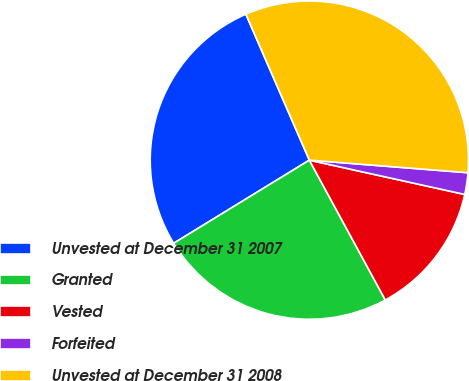<chart> <loc_0><loc_0><loc_500><loc_500><pie_chart><fcel>Unvested at December 31 2007<fcel>Granted<fcel>Vested<fcel>Forfeited<fcel>Unvested at December 31 2008<nl><fcel>27.22%<fcel>24.17%<fcel>13.62%<fcel>2.2%<fcel>32.79%<nl></chart> 